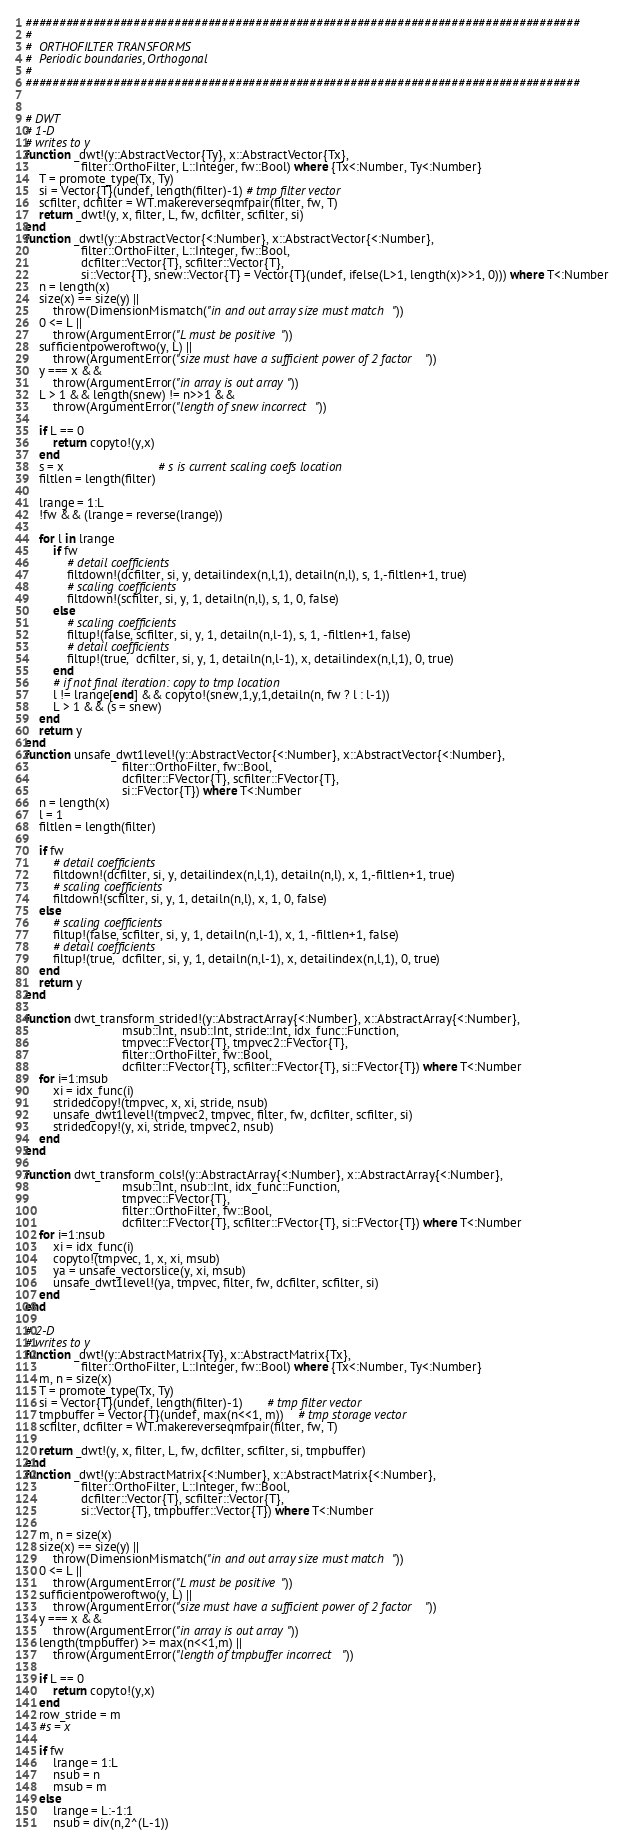<code> <loc_0><loc_0><loc_500><loc_500><_Julia_>
##################################################################################
#
#  ORTHOFILTER TRANSFORMS
#  Periodic boundaries, Orthogonal
#
##################################################################################


# DWT
# 1-D
# writes to y
function _dwt!(y::AbstractVector{Ty}, x::AbstractVector{Tx},
                filter::OrthoFilter, L::Integer, fw::Bool) where {Tx<:Number, Ty<:Number}
    T = promote_type(Tx, Ty)
    si = Vector{T}(undef, length(filter)-1) # tmp filter vector
    scfilter, dcfilter = WT.makereverseqmfpair(filter, fw, T)
    return _dwt!(y, x, filter, L, fw, dcfilter, scfilter, si)
end
function _dwt!(y::AbstractVector{<:Number}, x::AbstractVector{<:Number},
                filter::OrthoFilter, L::Integer, fw::Bool,
                dcfilter::Vector{T}, scfilter::Vector{T},
                si::Vector{T}, snew::Vector{T} = Vector{T}(undef, ifelse(L>1, length(x)>>1, 0))) where T<:Number
    n = length(x)
    size(x) == size(y) ||
        throw(DimensionMismatch("in and out array size must match"))
    0 <= L ||
        throw(ArgumentError("L must be positive"))
    sufficientpoweroftwo(y, L) ||
        throw(ArgumentError("size must have a sufficient power of 2 factor"))
    y === x &&
        throw(ArgumentError("in array is out array"))
    L > 1 && length(snew) != n>>1 &&
        throw(ArgumentError("length of snew incorrect"))

    if L == 0
        return copyto!(y,x)
    end
    s = x                           # s is current scaling coefs location
    filtlen = length(filter)

    lrange = 1:L
    !fw && (lrange = reverse(lrange))

    for l in lrange
        if fw
            # detail coefficients
            filtdown!(dcfilter, si, y, detailindex(n,l,1), detailn(n,l), s, 1,-filtlen+1, true)
            # scaling coefficients
            filtdown!(scfilter, si, y, 1, detailn(n,l), s, 1, 0, false)
        else
            # scaling coefficients
            filtup!(false, scfilter, si, y, 1, detailn(n,l-1), s, 1, -filtlen+1, false)
            # detail coefficients
            filtup!(true,  dcfilter, si, y, 1, detailn(n,l-1), x, detailindex(n,l,1), 0, true)
        end
        # if not final iteration: copy to tmp location
        l != lrange[end] && copyto!(snew,1,y,1,detailn(n, fw ? l : l-1))
        L > 1 && (s = snew)
    end
    return y
end
function unsafe_dwt1level!(y::AbstractVector{<:Number}, x::AbstractVector{<:Number},
                            filter::OrthoFilter, fw::Bool,
                            dcfilter::FVector{T}, scfilter::FVector{T},
                            si::FVector{T}) where T<:Number
    n = length(x)
    l = 1
    filtlen = length(filter)

    if fw
        # detail coefficients
        filtdown!(dcfilter, si, y, detailindex(n,l,1), detailn(n,l), x, 1,-filtlen+1, true)
        # scaling coefficients
        filtdown!(scfilter, si, y, 1, detailn(n,l), x, 1, 0, false)
    else
        # scaling coefficients
        filtup!(false, scfilter, si, y, 1, detailn(n,l-1), x, 1, -filtlen+1, false)
        # detail coefficients
        filtup!(true,  dcfilter, si, y, 1, detailn(n,l-1), x, detailindex(n,l,1), 0, true)
    end
    return y
end

function dwt_transform_strided!(y::AbstractArray{<:Number}, x::AbstractArray{<:Number},
                            msub::Int, nsub::Int, stride::Int, idx_func::Function,
                            tmpvec::FVector{T}, tmpvec2::FVector{T},
                            filter::OrthoFilter, fw::Bool,
                            dcfilter::FVector{T}, scfilter::FVector{T}, si::FVector{T}) where T<:Number
    for i=1:msub
        xi = idx_func(i)
        stridedcopy!(tmpvec, x, xi, stride, nsub)
        unsafe_dwt1level!(tmpvec2, tmpvec, filter, fw, dcfilter, scfilter, si)
        stridedcopy!(y, xi, stride, tmpvec2, nsub)
    end
end

function dwt_transform_cols!(y::AbstractArray{<:Number}, x::AbstractArray{<:Number},
                            msub::Int, nsub::Int, idx_func::Function,
                            tmpvec::FVector{T},
                            filter::OrthoFilter, fw::Bool,
                            dcfilter::FVector{T}, scfilter::FVector{T}, si::FVector{T}) where T<:Number
    for i=1:nsub
        xi = idx_func(i)
        copyto!(tmpvec, 1, x, xi, msub)
        ya = unsafe_vectorslice(y, xi, msub)
        unsafe_dwt1level!(ya, tmpvec, filter, fw, dcfilter, scfilter, si)
    end
end

# 2-D
# writes to y
function _dwt!(y::AbstractMatrix{Ty}, x::AbstractMatrix{Tx},
                filter::OrthoFilter, L::Integer, fw::Bool) where {Tx<:Number, Ty<:Number}
    m, n = size(x)
    T = promote_type(Tx, Ty)
    si = Vector{T}(undef, length(filter)-1)       # tmp filter vector
    tmpbuffer = Vector{T}(undef, max(n<<1, m))    # tmp storage vector
    scfilter, dcfilter = WT.makereverseqmfpair(filter, fw, T)

    return _dwt!(y, x, filter, L, fw, dcfilter, scfilter, si, tmpbuffer)
end
function _dwt!(y::AbstractMatrix{<:Number}, x::AbstractMatrix{<:Number},
                filter::OrthoFilter, L::Integer, fw::Bool,
                dcfilter::Vector{T}, scfilter::Vector{T},
                si::Vector{T}, tmpbuffer::Vector{T}) where T<:Number

    m, n = size(x)
    size(x) == size(y) ||
        throw(DimensionMismatch("in and out array size must match"))
    0 <= L ||
        throw(ArgumentError("L must be positive"))
    sufficientpoweroftwo(y, L) ||
        throw(ArgumentError("size must have a sufficient power of 2 factor"))
    y === x &&
        throw(ArgumentError("in array is out array"))
    length(tmpbuffer) >= max(n<<1,m) ||
        throw(ArgumentError("length of tmpbuffer incorrect"))

    if L == 0
        return copyto!(y,x)
    end
    row_stride = m
    #s = x

    if fw
        lrange = 1:L
        nsub = n
        msub = m
    else
        lrange = L:-1:1
        nsub = div(n,2^(L-1))</code> 